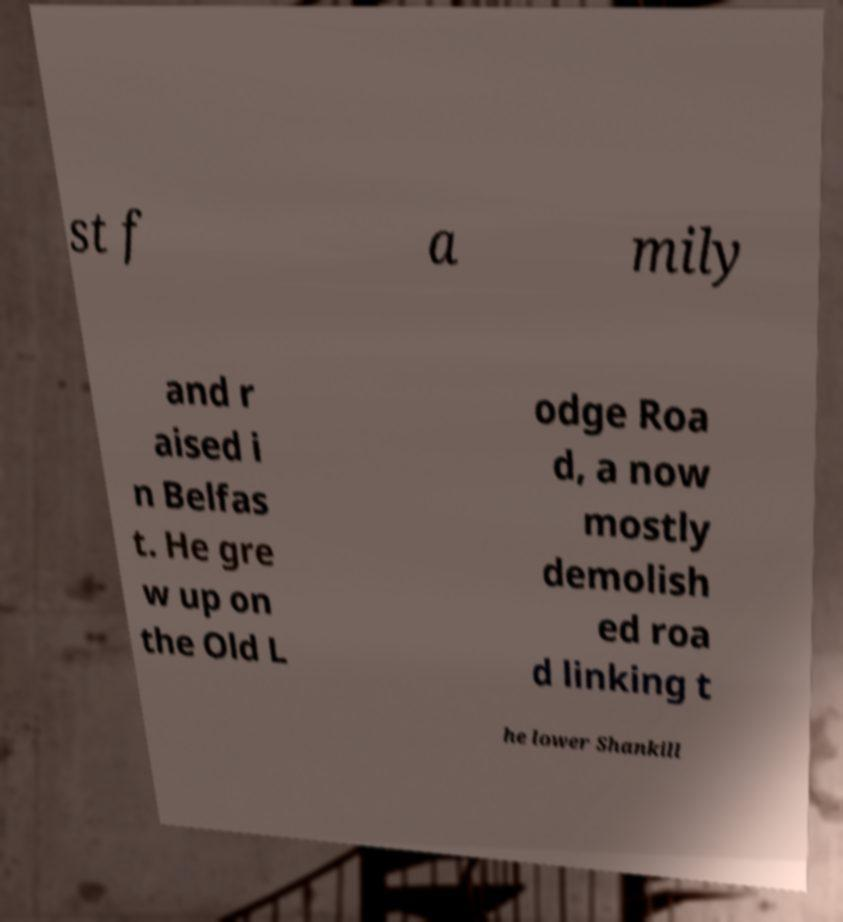Could you assist in decoding the text presented in this image and type it out clearly? st f a mily and r aised i n Belfas t. He gre w up on the Old L odge Roa d, a now mostly demolish ed roa d linking t he lower Shankill 